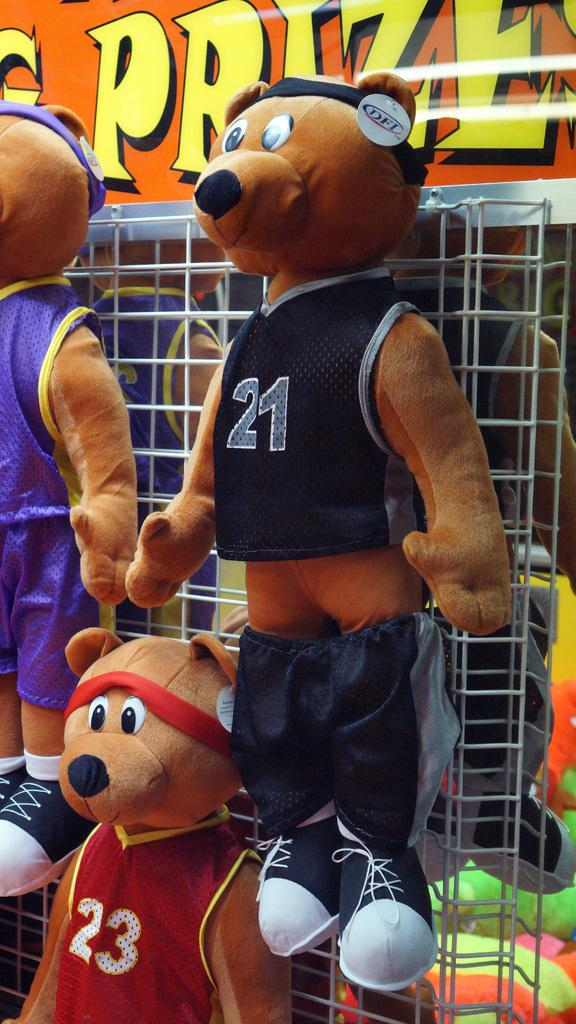<image>
Offer a succinct explanation of the picture presented. Bear wearing a jersey number 21 hanging on a fence. 